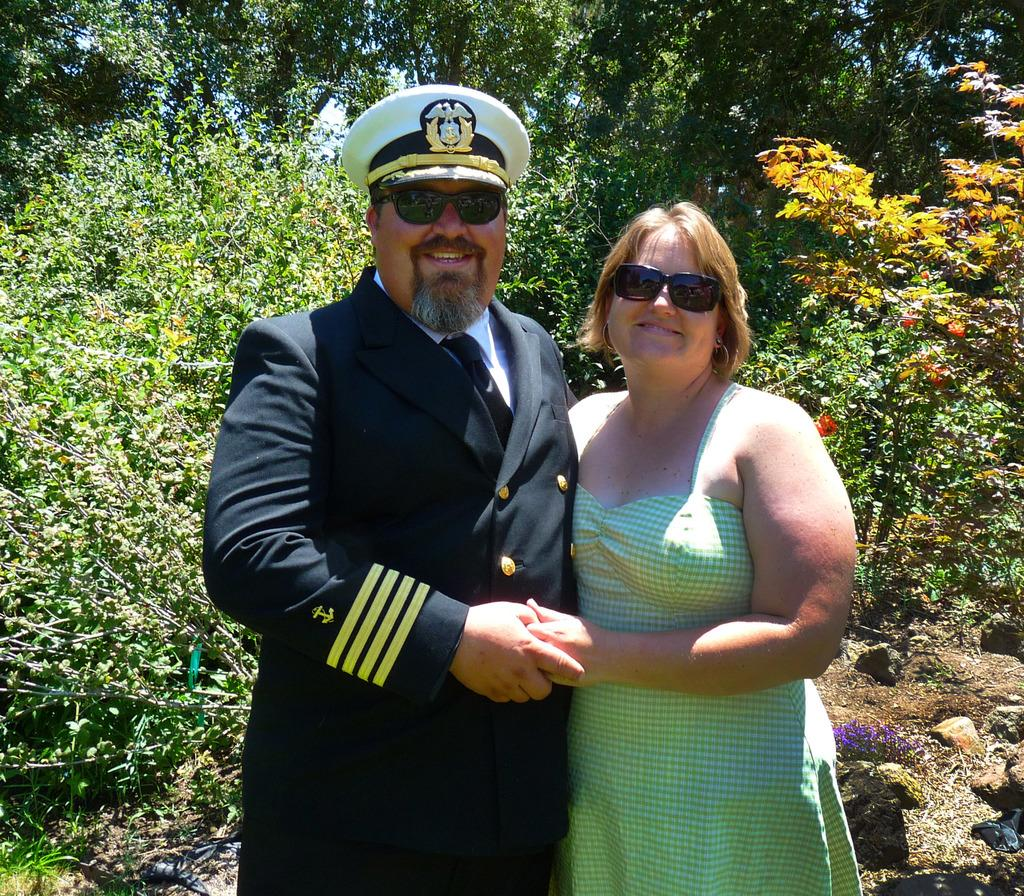What are the persons in the image doing? The persons in the image are standing on the ground and holding their hands. What can be seen in the background of the image? There are trees with flowers in the background. What type of vegetable is being used as a quilt in the image? There is no vegetable or quilt present in the image. What shape is the circle in the image? There is no circle present in the image. 